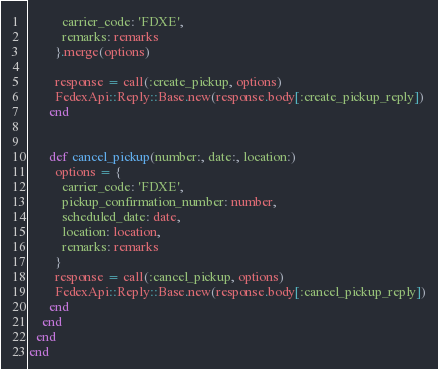<code> <loc_0><loc_0><loc_500><loc_500><_Ruby_>          carrier_code: 'FDXE',
          remarks: remarks
        }.merge(options)

        response = call(:create_pickup, options)
        FedexApi::Reply::Base.new(response.body[:create_pickup_reply])
      end


      def cancel_pickup(number:, date:, location:)
        options = {
          carrier_code: 'FDXE',
          pickup_confirmation_number: number,
          scheduled_date: date,
          location: location,
          remarks: remarks
        }
        response = call(:cancel_pickup, options)
        FedexApi::Reply::Base.new(response.body[:cancel_pickup_reply])
      end
    end
  end
end
</code> 